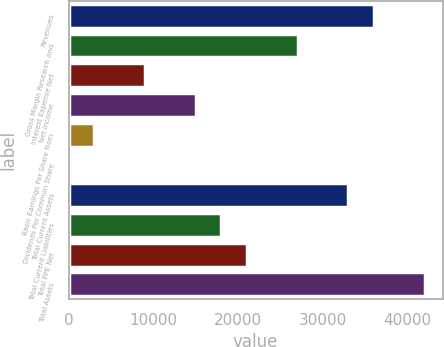Convert chart. <chart><loc_0><loc_0><loc_500><loc_500><bar_chart><fcel>Revenues<fcel>Gross Margin Research and<fcel>Interest Expense Net<fcel>Net Income<fcel>Basic Earnings Per Share from<fcel>Dividends Per Common Share<fcel>Total Current Assets<fcel>Total Current Liabilities<fcel>Total PPE Net<fcel>Total Assets<nl><fcel>35999.6<fcel>27000.2<fcel>9001.38<fcel>15001<fcel>3001.78<fcel>1.98<fcel>32999.8<fcel>18000.8<fcel>21000.6<fcel>41999.2<nl></chart> 